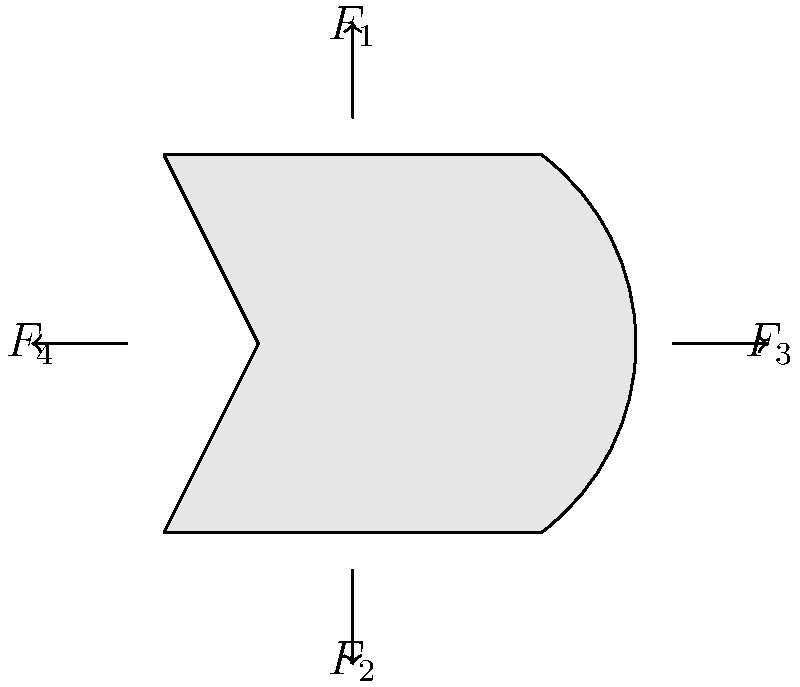A medical-grade N95 mask is subjected to various forces during use, as shown in the force diagram. $F_1$ and $F_2$ represent the upward and downward forces from the elastic straps, while $F_3$ and $F_4$ represent the outward forces due to breathing. If $F_1 = 2$ N, $F_2 = 2$ N, $F_3 = 1$ N, and $F_4 = 1$ N, what is the net force acting on the mask? To find the net force acting on the mask, we need to consider all forces in each direction:

1. Vertical forces:
   - Upward force $F_1 = 2$ N
   - Downward force $F_2 = 2$ N
   Net vertical force = $F_1 - F_2 = 2$ N - 2 N = 0 N

2. Horizontal forces:
   - Rightward force $F_3 = 1$ N
   - Leftward force $F_4 = 1$ N
   Net horizontal force = $F_3 - F_4 = 1$ N - 1 N = 0 N

3. Calculate the net force:
   Net force = $\sqrt{(\text{Net vertical force})^2 + (\text{Net horizontal force})^2}$
   Net force = $\sqrt{0^2 + 0^2} = 0$ N

The net force is zero because all opposing forces are equal in magnitude, creating a balanced system.
Answer: 0 N 